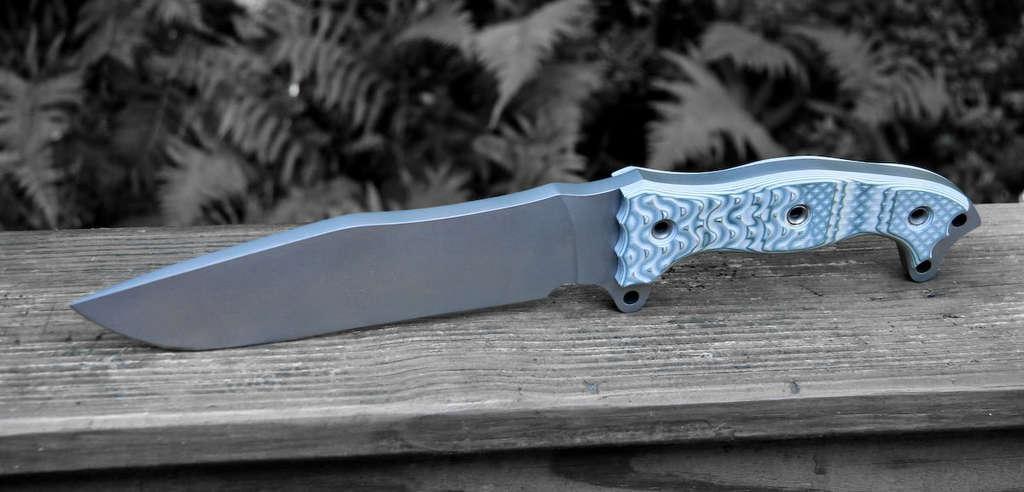In one or two sentences, can you explain what this image depicts? To the bottom of the image there is a wooden surface with knife on it. And to the top of the image there are leaves. 